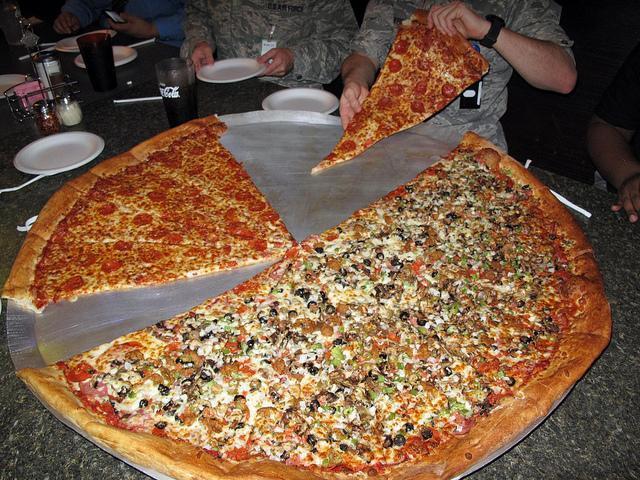How many pizzas are there?
Give a very brief answer. 2. How many people can you see?
Give a very brief answer. 4. 